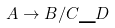Convert formula to latex. <formula><loc_0><loc_0><loc_500><loc_500>A \rightarrow B / C \_ D</formula> 